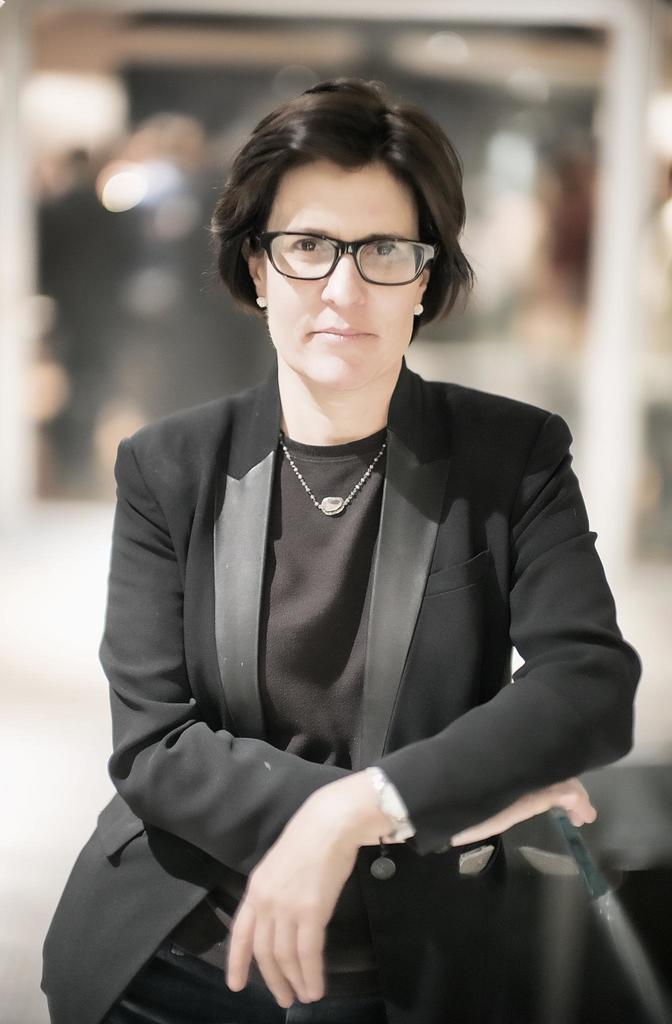Please provide a concise description of this image. In the image there is a woman standing and posing for the photo,she is wearing black dress and the background of the woman is blur. 